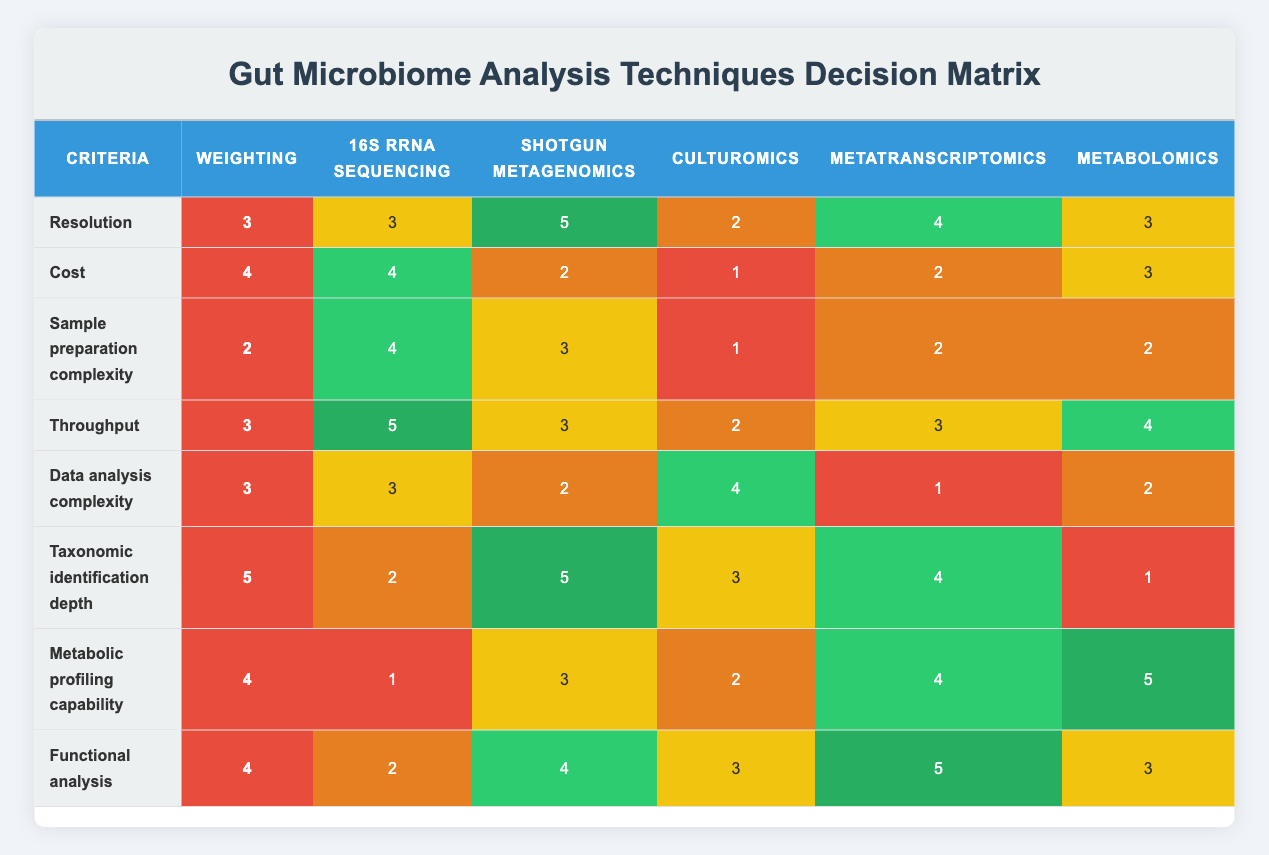What is the highest scoring technique in terms of resolution? Looking at the "Resolution" row, the scores are: 16S rRNA sequencing (3), Shotgun metagenomics (5), Culturomics (2), Metatranscriptomics (4), and Metabolomics (3). The highest score is 5, corresponding to Shotgun metagenomics.
Answer: Shotgun metagenomics What is the total weight for cost and data analysis complexity? The weight for "Cost" is 4 and for "Data analysis complexity" it is also 3. Adding these weights gives 4 + 3 = 7.
Answer: 7 Does Metabolomics have the lowest score for metabolic profiling capability? For "Metabolic profiling capability", Metabolomics has a score of 5, while the scores for other techniques are: 16S rRNA sequencing (1), Shotgun metagenomics (3), Culturomics (2), and Metatranscriptomics (4). Since Metabolomics has the highest score (5), it does not have the lowest score.
Answer: No Which technique has the highest score in both taxonomic identification depth and functional analysis? In "Taxonomic identification depth", the scores are: 16S rRNA sequencing (2), Shotgun metagenomics (5), Culturomics (3), Metatranscriptomics (4), and Metabolomics (1). The highest score of 5 belongs to Shotgun metagenomics. In "Functional analysis", the scores are: 16S rRNA sequencing (2), Shotgun metagenomics (4), Culturomics (3), Metatranscriptomics (5), and Metabolomics (3) where the highest score of 5 belongs to Metatranscriptomics. Thus, no technique has the highest score in both criteria simultaneously.
Answer: None What is the average score of 16S rRNA sequencing across all criteria? The scores for 16S rRNA sequencing are: 3, 4, 4, 5, 3, 2, 1, and 2. To find the average, we sum these scores: 3 + 4 + 4 + 5 + 3 + 2 + 1 + 2 = 24. There are 8 scores, so the average is 24 / 8 = 3.
Answer: 3 